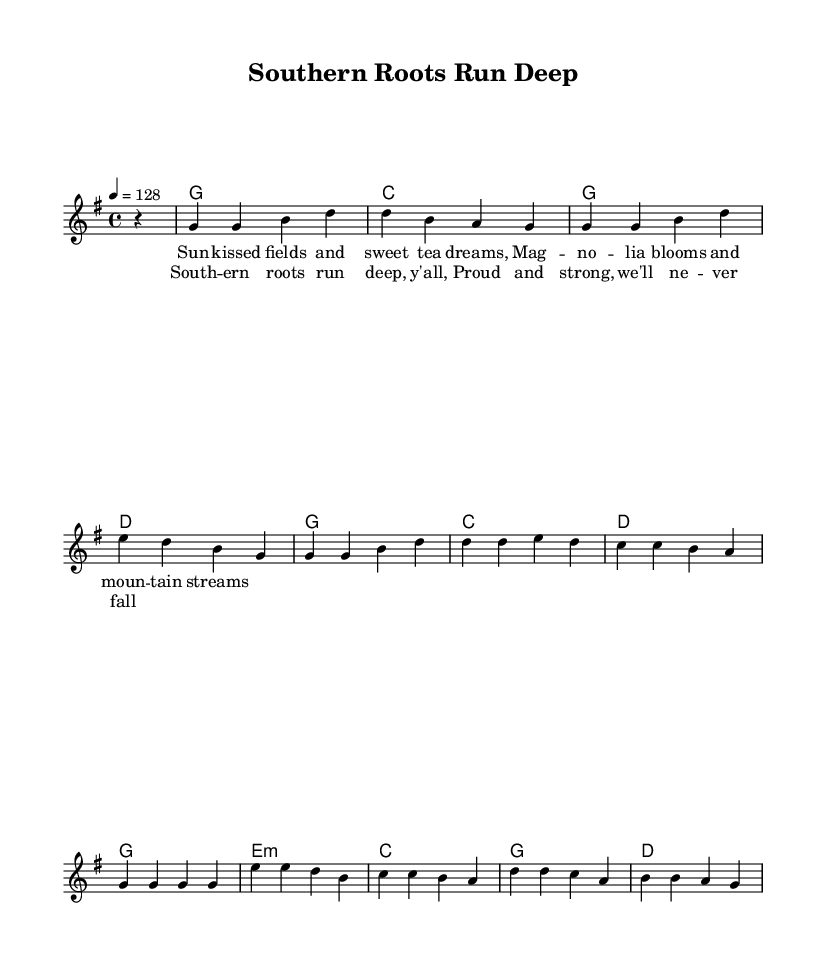What is the key signature of this music? The key signature is G major, which has one sharp (F#). This can be identified by looking at the beginning of the staff where the sharp indicates the key.
Answer: G major What is the time signature of this piece? The time signature is 4/4, which is evident from the notation at the beginning of the staff. This indicates there are four beats in each measure.
Answer: 4/4 What is the tempo marking of the song? The tempo marking indicates that the piece should be played at 128 beats per minute, as shown in the tempo notation.
Answer: 128 How many measures are in the melody? The melody has a total of 8 measures, which can be counted by looking at the measure lines throughout the staff implementation.
Answer: 8 What chord is used in the first measure? The first measure shows a G major chord, which can be identified in the chord names section at the beginning of the score.
Answer: G What is the lyrical theme of the first verse? The first verse speaks about nature and Southern culture, as indicated by the lyrics. The lyrics highlight elements like sun-kissed fields and Magnolia blooms, which celebrate Southern life.
Answer: Nature What cultural value is emphasized in the chorus? The chorus emphasizes pride and resilience, as indicated by the lyrics "Southern roots run deep, y'all, Proud and strong, we'll never fall." This reflects a celebration of Southern values.
Answer: Pride 